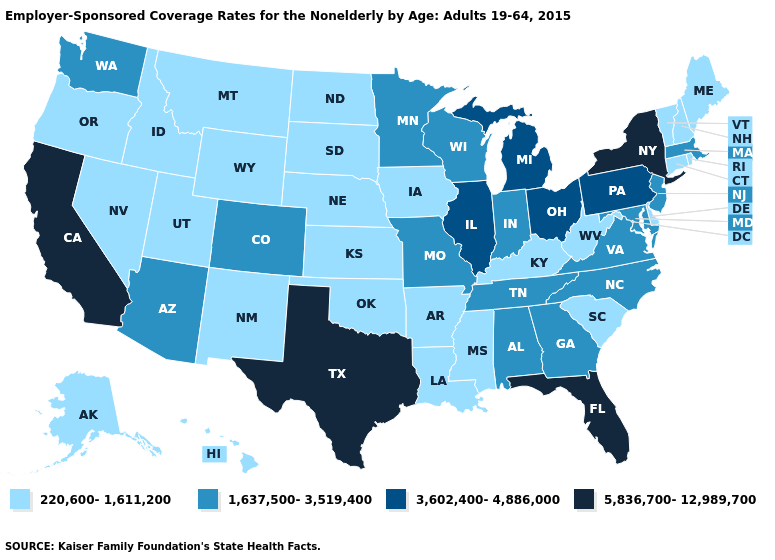What is the highest value in states that border New Jersey?
Be succinct. 5,836,700-12,989,700. Does Connecticut have the highest value in the USA?
Quick response, please. No. What is the lowest value in the MidWest?
Give a very brief answer. 220,600-1,611,200. What is the value of North Dakota?
Concise answer only. 220,600-1,611,200. What is the highest value in states that border Florida?
Answer briefly. 1,637,500-3,519,400. Name the states that have a value in the range 1,637,500-3,519,400?
Write a very short answer. Alabama, Arizona, Colorado, Georgia, Indiana, Maryland, Massachusetts, Minnesota, Missouri, New Jersey, North Carolina, Tennessee, Virginia, Washington, Wisconsin. What is the value of Michigan?
Write a very short answer. 3,602,400-4,886,000. Does the first symbol in the legend represent the smallest category?
Be succinct. Yes. Does Illinois have the highest value in the USA?
Concise answer only. No. Does the first symbol in the legend represent the smallest category?
Answer briefly. Yes. Does Arizona have a higher value than Colorado?
Quick response, please. No. Which states have the lowest value in the South?
Write a very short answer. Arkansas, Delaware, Kentucky, Louisiana, Mississippi, Oklahoma, South Carolina, West Virginia. Which states hav the highest value in the MidWest?
Keep it brief. Illinois, Michigan, Ohio. Which states have the highest value in the USA?
Quick response, please. California, Florida, New York, Texas. Name the states that have a value in the range 5,836,700-12,989,700?
Concise answer only. California, Florida, New York, Texas. 